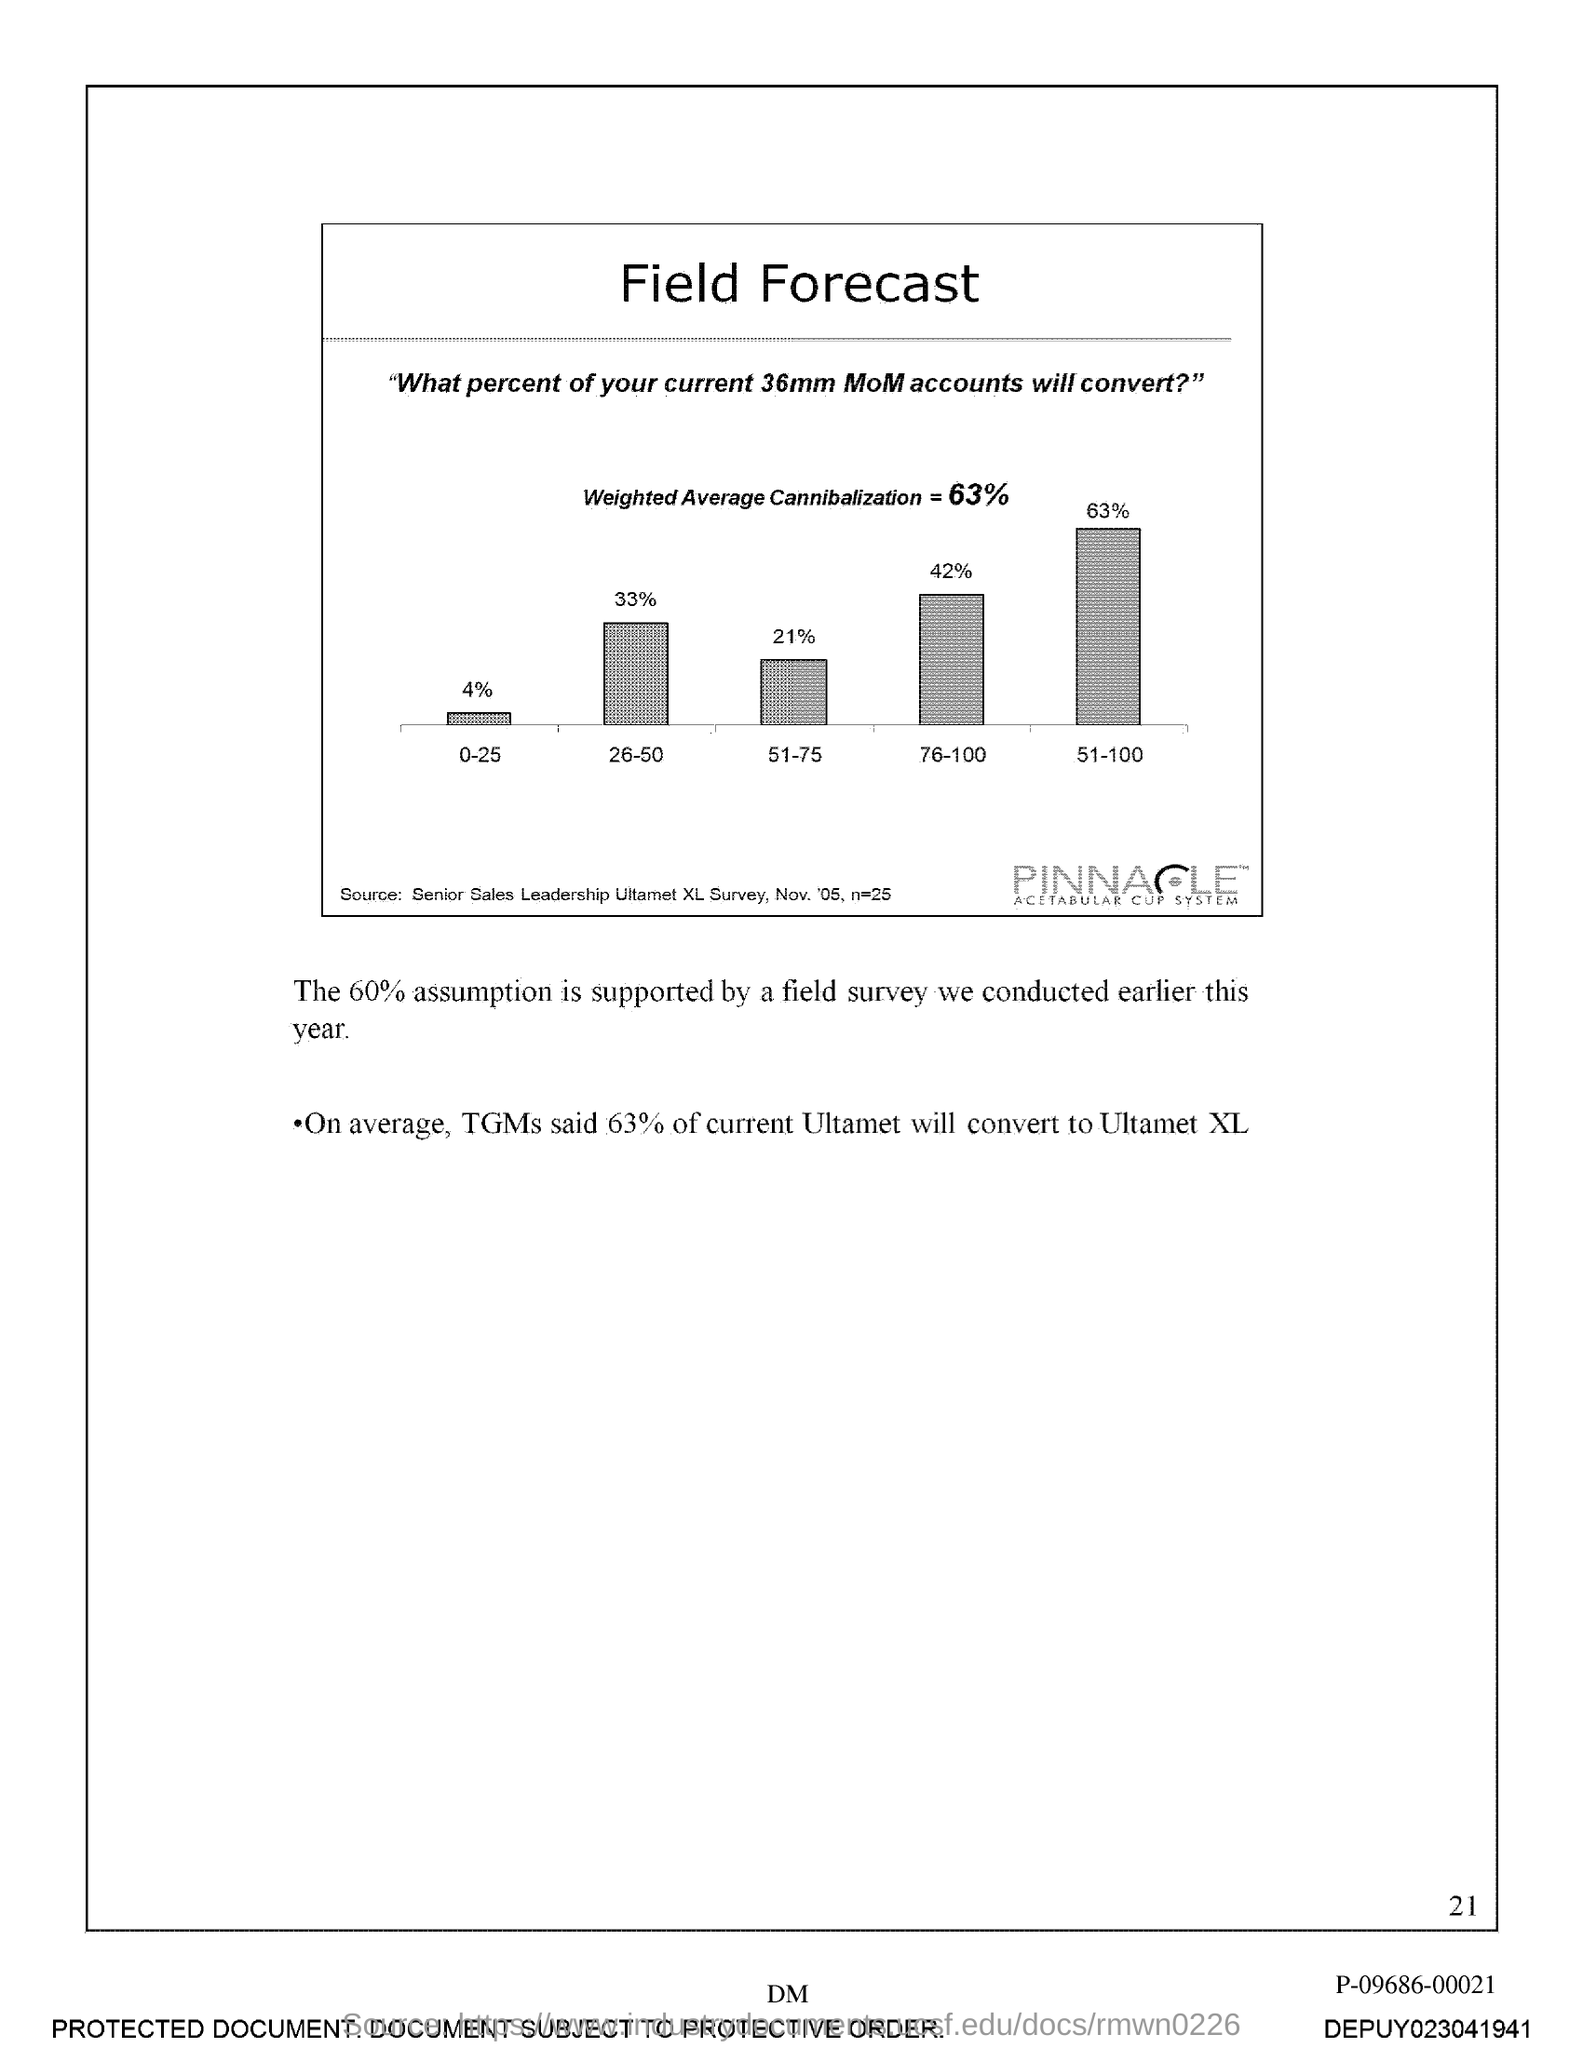What is the title of the graph?
Provide a succinct answer. Field forecast. How much is the weighted average cannibalization?
Give a very brief answer. 63%. How much percentage of the assumption is supported by the field survey?
Give a very brief answer. 60%. On average how much of current ultamet will convert to ultamet xl?
Ensure brevity in your answer.  63%. 